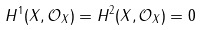<formula> <loc_0><loc_0><loc_500><loc_500>H ^ { 1 } ( X , { \mathcal { O } } _ { X } ) = H ^ { 2 } ( X , { \mathcal { O } } _ { X } ) = 0</formula> 